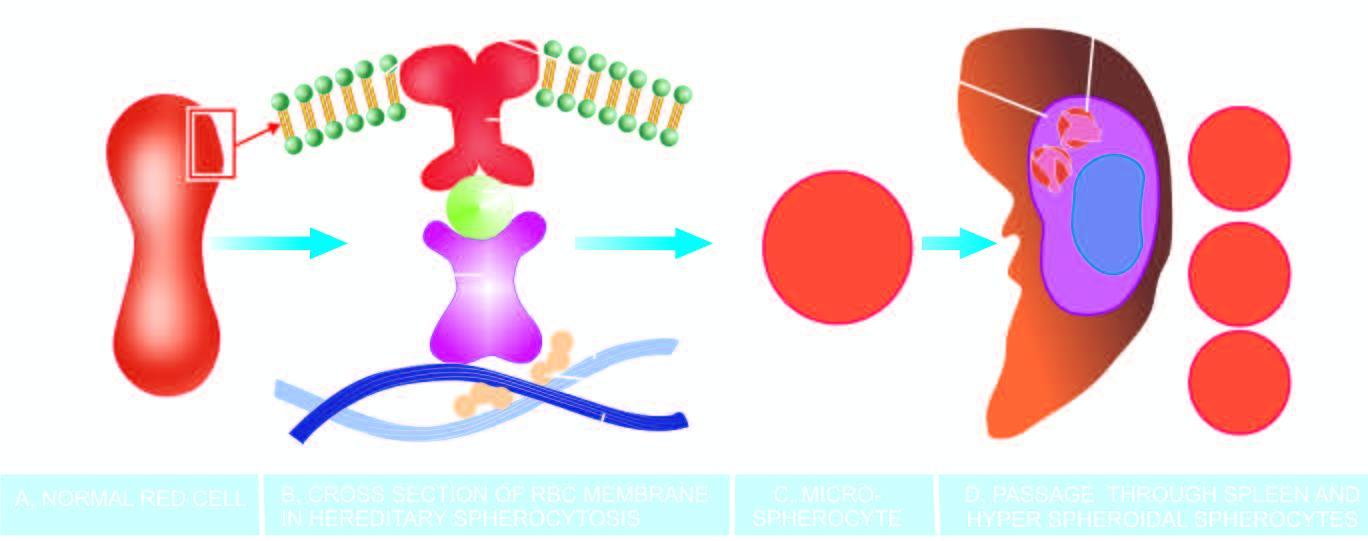does the wedge-shaped infarct result in spherical contour and small size so as to contain the given volume of haemoglobin in the deformed red cell?
Answer the question using a single word or phrase. No 